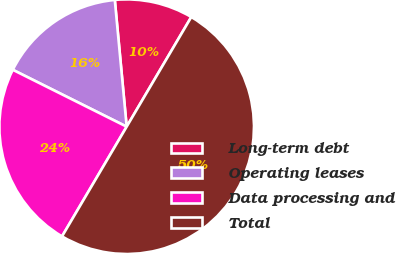<chart> <loc_0><loc_0><loc_500><loc_500><pie_chart><fcel>Long-term debt<fcel>Operating leases<fcel>Data processing and<fcel>Total<nl><fcel>9.96%<fcel>16.14%<fcel>23.9%<fcel>50.0%<nl></chart> 